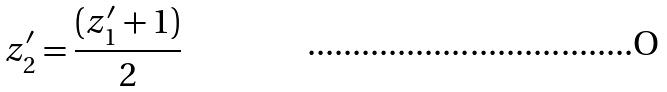Convert formula to latex. <formula><loc_0><loc_0><loc_500><loc_500>z _ { 2 } ^ { \prime } = \frac { ( z _ { 1 } ^ { \prime } + 1 ) } { 2 }</formula> 